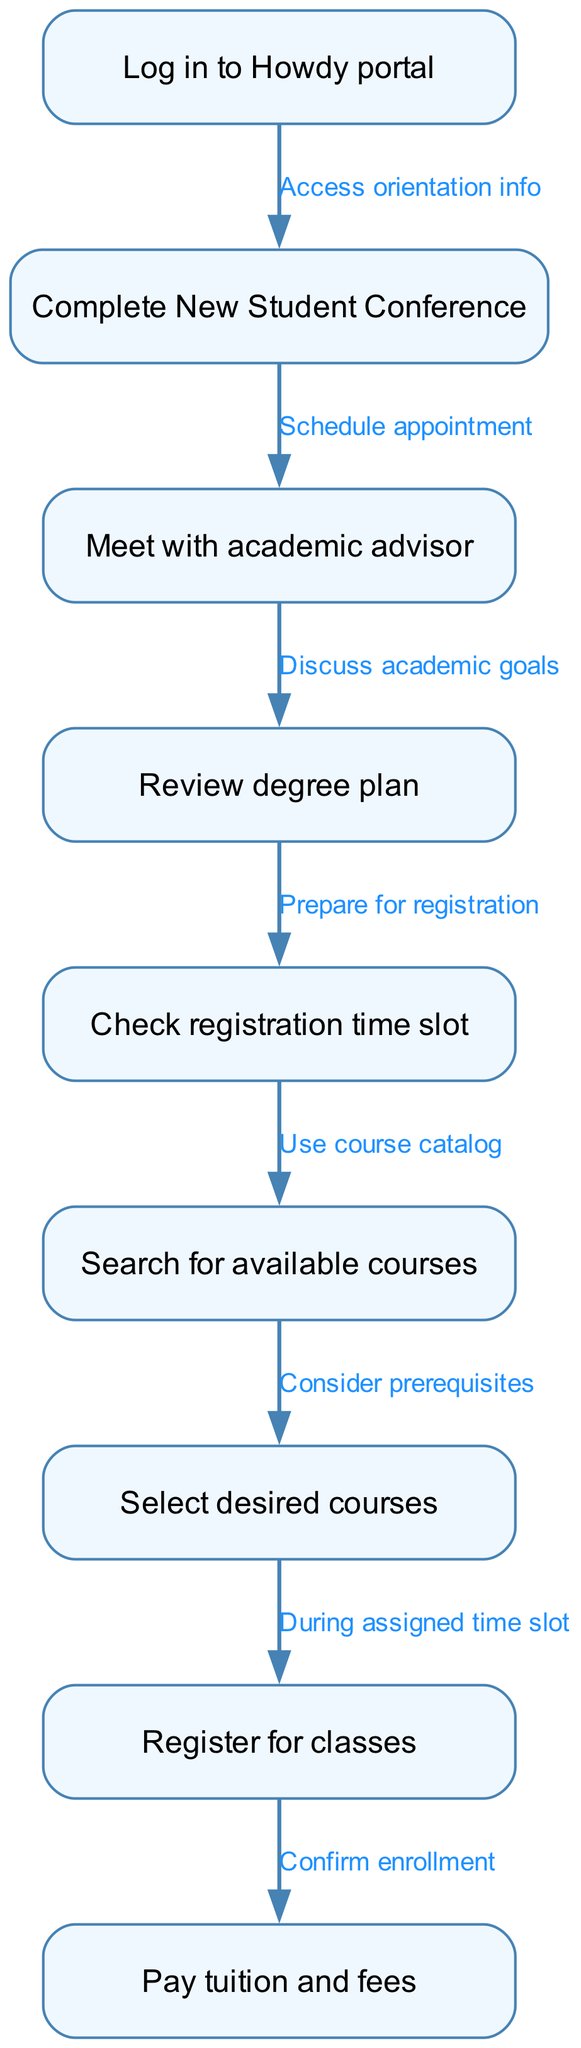What is the first step in the course registration process? The diagram shows that the first step is to "Log in to Howdy portal," which is the initial action before proceeding to the New Student Conference.
Answer: Log in to Howdy portal How many nodes are present in the diagram? By counting the nodes listed, there are a total of 9 distinct nodes representing different steps in the course registration process.
Answer: 9 What follows after completing the New Student Conference? The flow from the New Student Conference leads directly to meeting with the academic advisor, indicating this is the next action to take after the conference.
Answer: Meet with academic advisor What should you consider when searching for available courses? The diagram indicates that you need to "Consider prerequisites," which is a necessary step when you are searching for courses to take.
Answer: Consider prerequisites What is the last step before confirming enrollment? The edge from "Register for classes" to "Pay tuition and fees" indicates that paying tuition and fees comes right before confirming enrollment, completing the registration process.
Answer: Pay tuition and fees How does one access orientation information? The diagram shows that one can access information by logging in to the Howdy portal, which marks the beginning of the registration process.
Answer: Log in to Howdy portal What is the connection between selecting desired courses and registering for classes? The flow indicates that selecting desired courses occurs during the assigned time slot for registration, meaning you need to select courses first before you can register for them.
Answer: During assigned time slot Which step involves discussing academic goals? The step that involves discussing academic goals is "Meet with academic advisor," as indicated in the flowchart.
Answer: Meet with academic advisor 